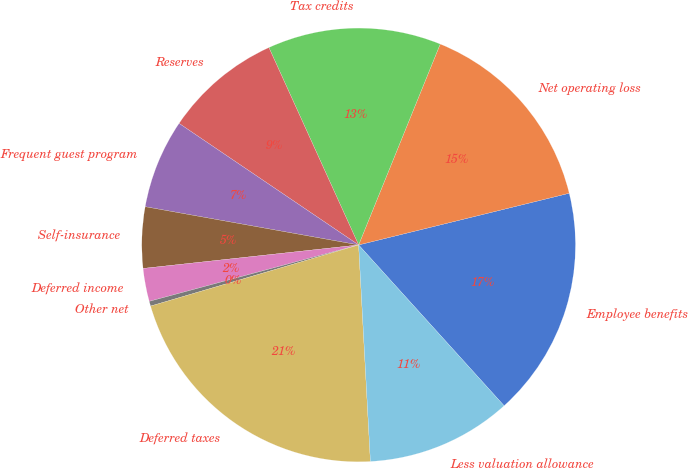Convert chart to OTSL. <chart><loc_0><loc_0><loc_500><loc_500><pie_chart><fcel>Employee benefits<fcel>Net operating loss<fcel>Tax credits<fcel>Reserves<fcel>Frequent guest program<fcel>Self-insurance<fcel>Deferred income<fcel>Other net<fcel>Deferred taxes<fcel>Less valuation allowance<nl><fcel>17.13%<fcel>15.03%<fcel>12.93%<fcel>8.74%<fcel>6.65%<fcel>4.55%<fcel>2.46%<fcel>0.36%<fcel>21.32%<fcel>10.84%<nl></chart> 